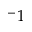Convert formula to latex. <formula><loc_0><loc_0><loc_500><loc_500>^ { - } 1</formula> 